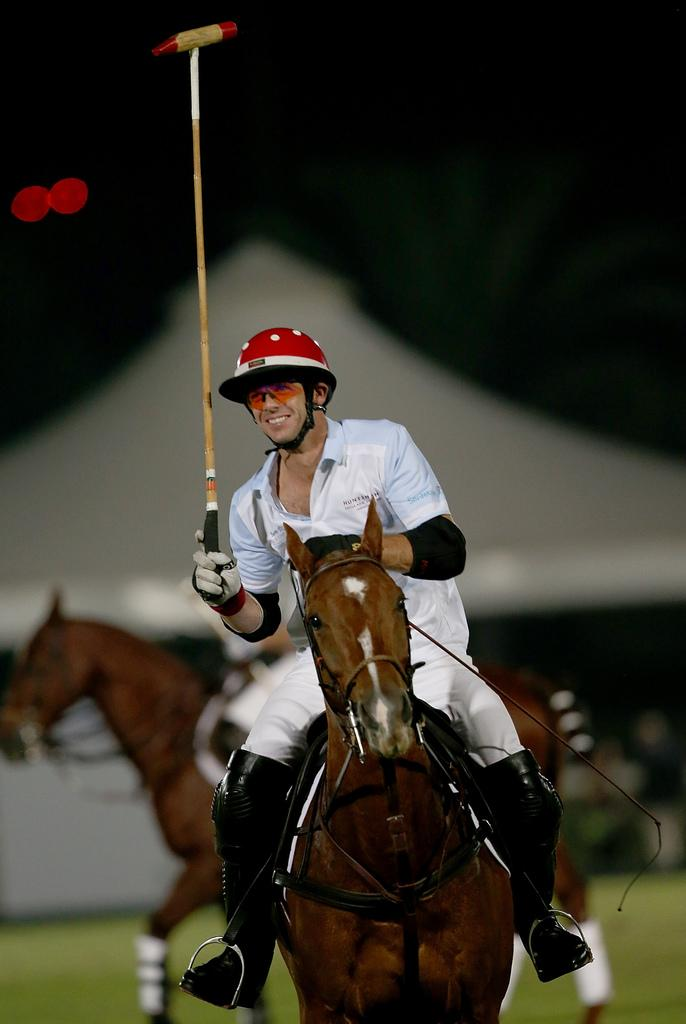Who is the main subject in the image? There is a man in the image. What is the man doing in the image? The man is sitting on a horse. What is the man holding in his right hand? The man is holding a stick in his right hand. Are there any other animals in the image besides the horse the man is sitting on? Yes, there is another horse in the image. How many ladybugs can be seen on the horse in the image? There are no ladybugs present in the image; it features a man sitting on a horse and holding a stick. What type of spoon is the man using to ride the horse in the image? There is no spoon present in the image, and the man is not using any utensil to ride the horse. 